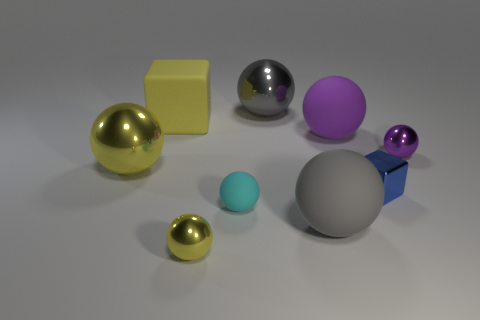Subtract all yellow balls. How many balls are left? 5 Add 1 rubber balls. How many objects exist? 10 Subtract all yellow spheres. How many spheres are left? 5 Subtract all red cylinders. How many gray spheres are left? 2 Add 3 large purple metallic objects. How many large purple metallic objects exist? 3 Subtract 0 blue cylinders. How many objects are left? 9 Subtract all spheres. How many objects are left? 2 Subtract 2 blocks. How many blocks are left? 0 Subtract all gray spheres. Subtract all brown cylinders. How many spheres are left? 5 Subtract all gray rubber things. Subtract all metal balls. How many objects are left? 4 